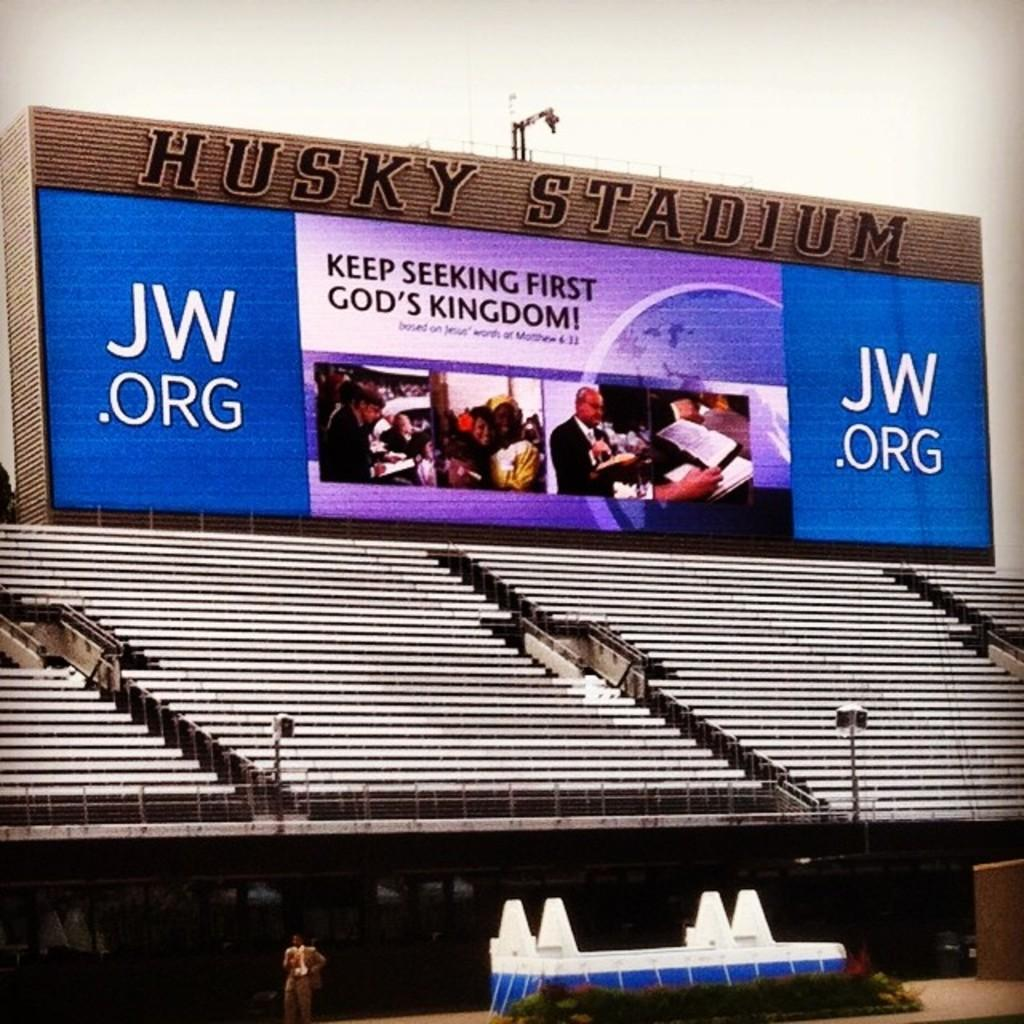<image>
Give a short and clear explanation of the subsequent image. Husky stadium with bleachers that include a jw.org banner 